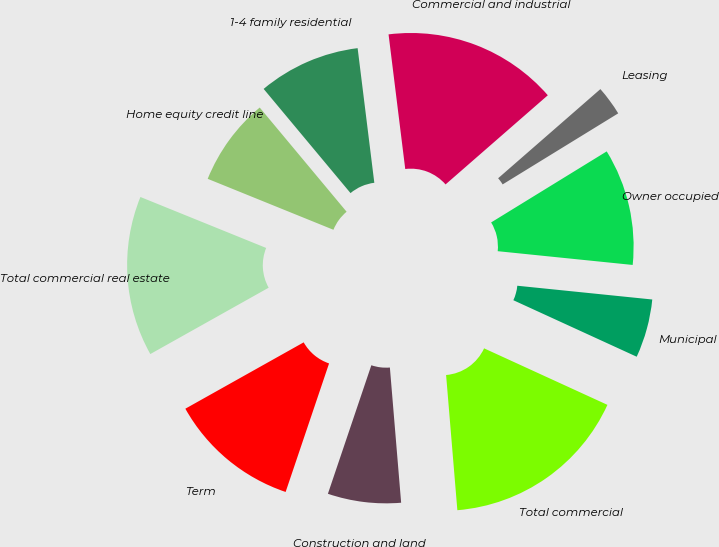Convert chart to OTSL. <chart><loc_0><loc_0><loc_500><loc_500><pie_chart><fcel>Commercial and industrial<fcel>Leasing<fcel>Owner occupied<fcel>Municipal<fcel>Total commercial<fcel>Construction and land<fcel>Term<fcel>Total commercial real estate<fcel>Home equity credit line<fcel>1-4 family residential<nl><fcel>15.55%<fcel>2.64%<fcel>10.39%<fcel>5.22%<fcel>16.84%<fcel>6.51%<fcel>11.68%<fcel>14.26%<fcel>7.81%<fcel>9.1%<nl></chart> 